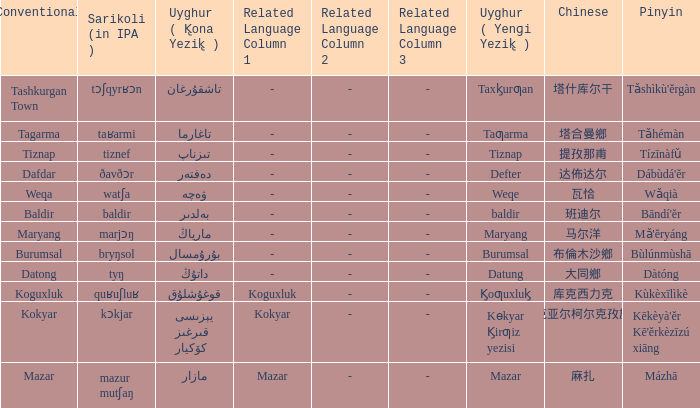Name the uyghur for  瓦恰 ۋەچە. 